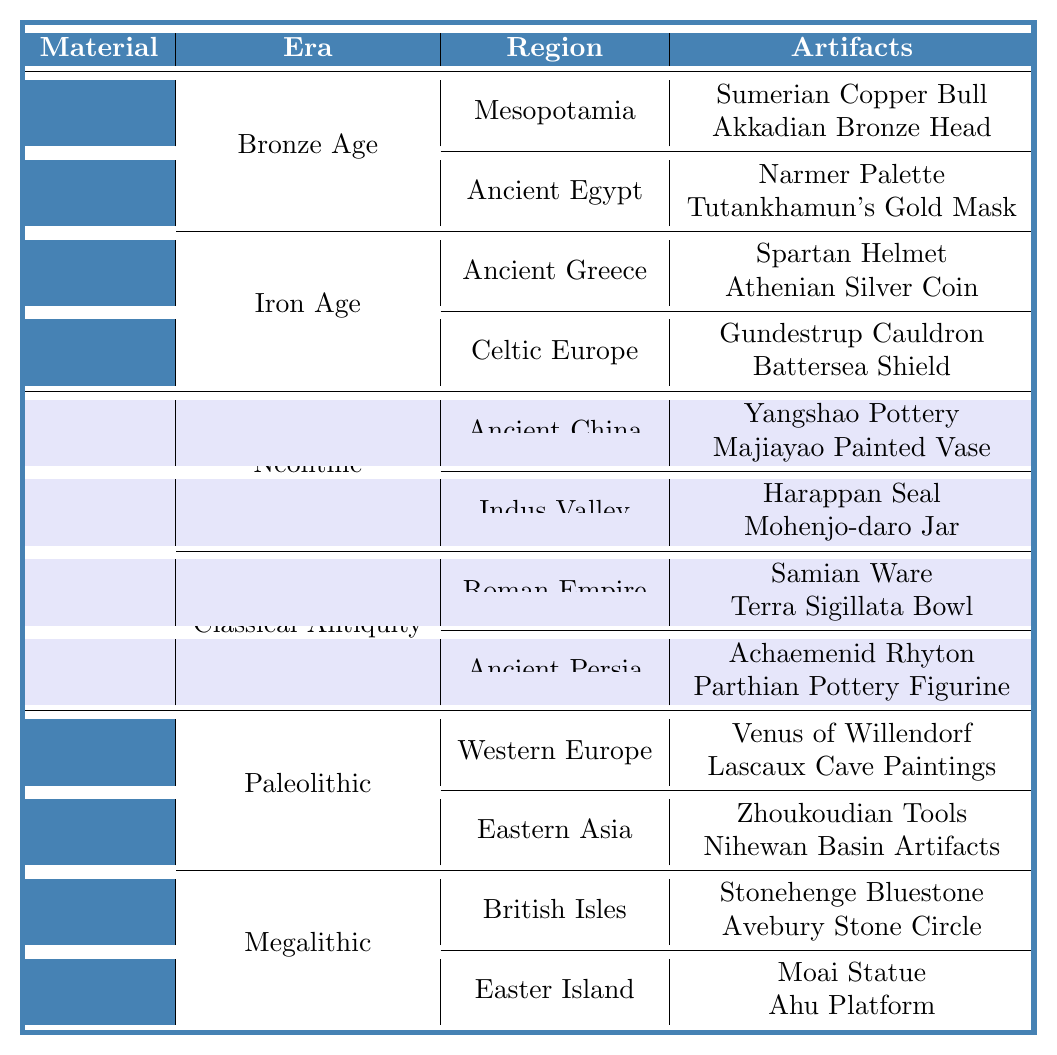What artifacts are listed under Ancient Egypt in the Bronze Age? The table shows that under the Bronze Age and the region of Ancient Egypt, the artifacts listed are the Narmer Palette, Tutankhamun's Gold Mask, and Horus Copper Statue.
Answer: Narmer Palette, Tutankhamun's Gold Mask, Horus Copper Statue How many artifacts are listed for the Iron Age in Celtic Europe? For the Iron Age in Celtic Europe, there are three artifacts listed: Gundestrup Cauldron, Battersea Shield, and Coligny Calendar.
Answer: 3 Is the Lascaux Cave Paintings considered a Paleolithic artifact? Yes, according to the table, the Lascaux Cave Paintings are categorized under the Paleolithic era and listed with other artifacts from Western Europe.
Answer: Yes Which material has the most artifacts listed in the table? First, count all artifacts: Metal has 6, Ceramic has 6, and Stone has 6. Therefore, all materials are equal in the number of artifacts listed.
Answer: Tie (6 artifacts each) Which region has the least number of listed artifacts? By examining the regions, all of them (Mesopotamia, Ancient Egypt, Ancient Greece, Celtic Europe, Ancient China, Indus Valley, Western Europe, Eastern Asia, British Isles, and Easter Island) have 3 artifacts listed, showing no region has fewer.
Answer: Tie (3 artifacts each) What is the total number of artifacts listed under the Ceramic category? The Ceramic category consists of two eras: Neolithic (3 artifacts) and Classical Antiquity (3 artifacts). Therefore, the total is 3 + 3 = 6.
Answer: 6 Are there any artifacts listed from the post-Iron Age in the table? No, the table includes only artifacts from the Bronze Age, Iron Age, Neolithic, Classical Antiquity, Paleolithic, and Megalithic eras.
Answer: No Which artifact from the Neolithic era is associated with Ancient China? The table indicates that Yangshao Pottery, Majiayao Painted Vase, and Longshan Black Pottery are the artifacts listed in the Neolithic era for Ancient China.
Answer: Yangshao Pottery, Majiayao Painted Vase, Longshan Black Pottery How many different eras are represented in the table for the material Stone? The table shows that there are two eras listed for the material Stone: Paleolithic and Megalithic, making a total of 2.
Answer: 2 If we look at the Bronze Age in Mesopotamia, how many different types of artifacts are shown? The Bronze Age in Mesopotamia has three artifacts listed: Sumerian Copper Bull, Akkadian Bronze Head, Babylonian Gold Necklace. Thus, there are 3 types of artifacts.
Answer: 3 